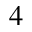<formula> <loc_0><loc_0><loc_500><loc_500>^ { 4 }</formula> 